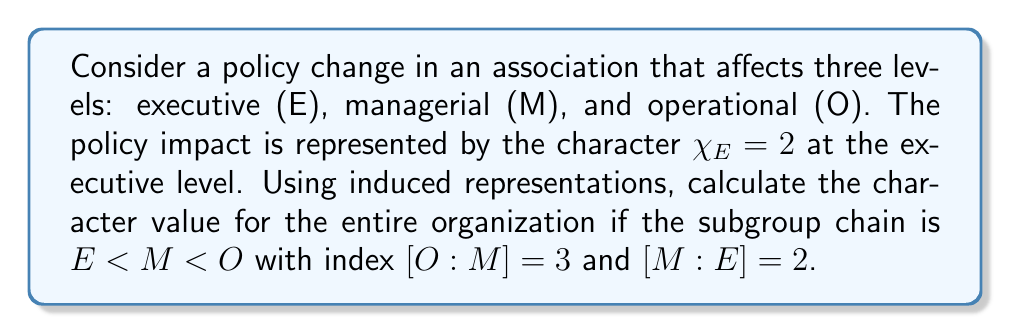Show me your answer to this math problem. To solve this problem, we'll use the theory of induced representations:

1) First, we need to understand the subgroup chain:
   $E < M < O$, where $E$ is a subgroup of $M$, and $M$ is a subgroup of $O$.

2) We're given that $[O:M] = 3$ and $[M:E] = 2$. This means:
   - There are 3 cosets of $M$ in $O$
   - There are 2 cosets of $E$ in $M$

3) The character at the executive level is given as $\chi_E = 2$.

4) To induce this representation from $E$ to $M$, we use the formula:
   $$\chi_M = \chi_E \uparrow_E^M = [M:E] \cdot \chi_E = 2 \cdot 2 = 4$$

5) Now, we need to induce from $M$ to $O$:
   $$\chi_O = \chi_M \uparrow_M^O = [O:M] \cdot \chi_M = 3 \cdot 4 = 12$$

6) Therefore, the character value for the entire organization is 12.

This result indicates that the policy change, which had an impact of 2 at the executive level, has an amplified effect of 12 when considered across all levels of the organization.
Answer: 12 